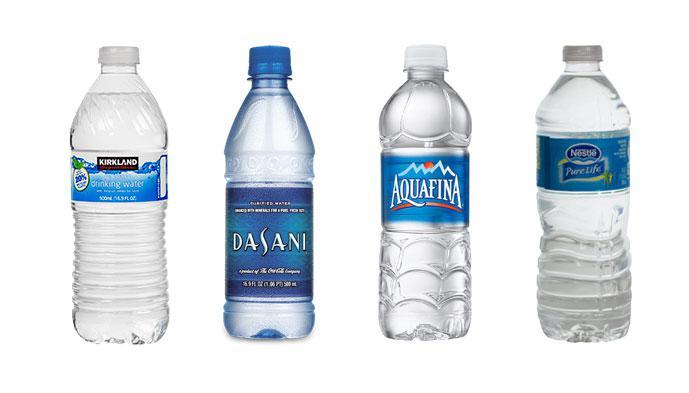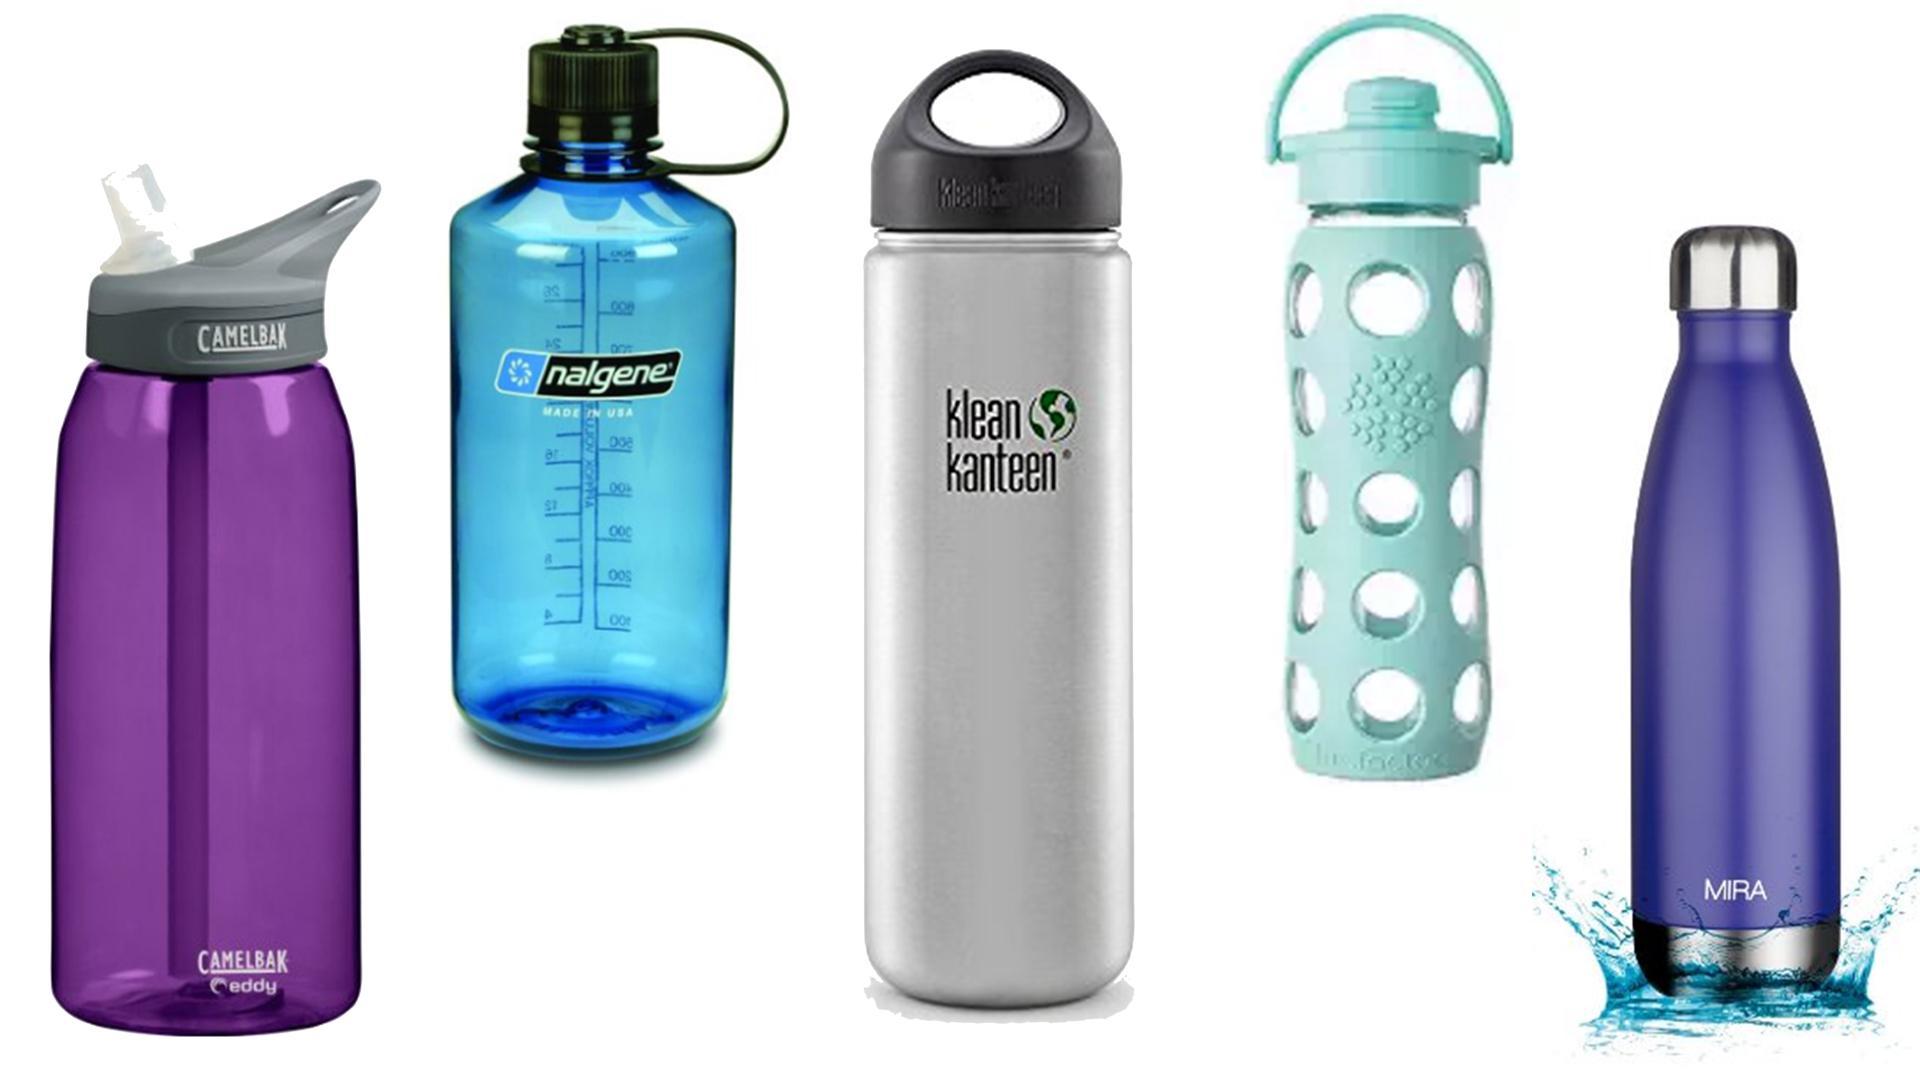The first image is the image on the left, the second image is the image on the right. Examine the images to the left and right. Is the description "Some of the containers don't have blue caps." accurate? Answer yes or no. Yes. The first image is the image on the left, the second image is the image on the right. Evaluate the accuracy of this statement regarding the images: "There are exactly four bottles of water in one of the images.". Is it true? Answer yes or no. Yes. 